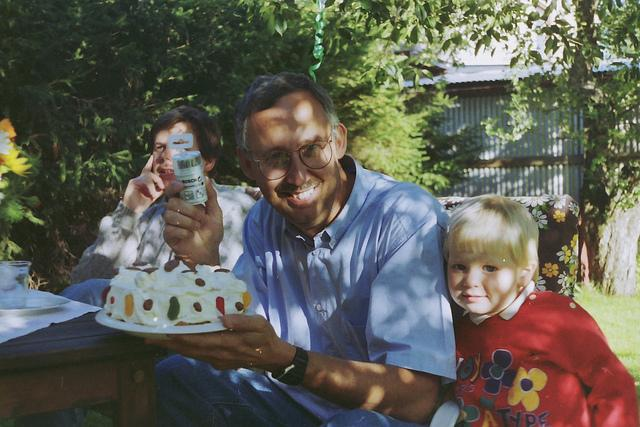What this man doing?

Choices:
A) buying cake
B) smashing cake
C) decorating cake
D) tasting cake decorating cake 